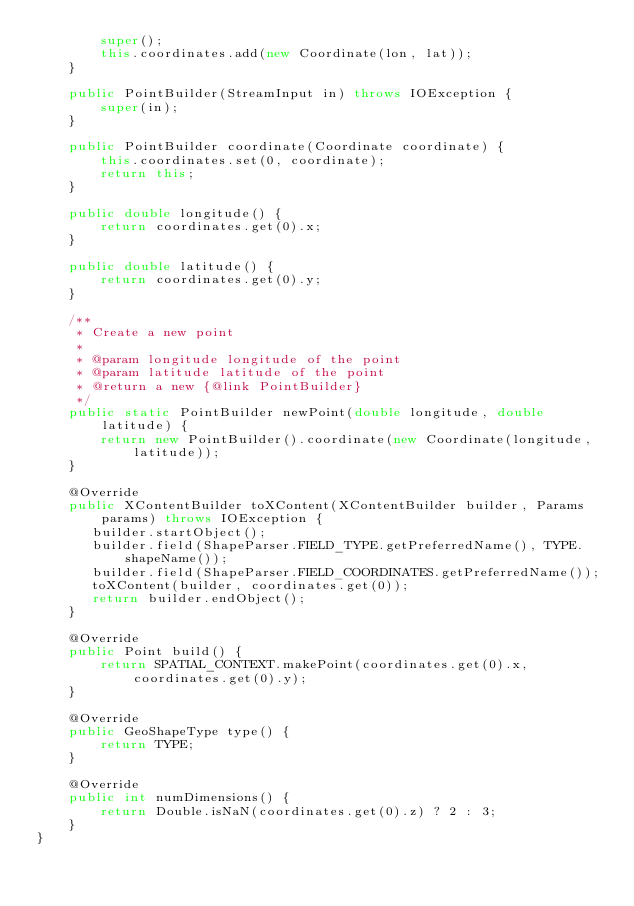Convert code to text. <code><loc_0><loc_0><loc_500><loc_500><_Java_>        super();
        this.coordinates.add(new Coordinate(lon, lat));
    }

    public PointBuilder(StreamInput in) throws IOException {
        super(in);
    }

    public PointBuilder coordinate(Coordinate coordinate) {
        this.coordinates.set(0, coordinate);
        return this;
    }

    public double longitude() {
        return coordinates.get(0).x;
    }

    public double latitude() {
        return coordinates.get(0).y;
    }

    /**
     * Create a new point
     *
     * @param longitude longitude of the point
     * @param latitude latitude of the point
     * @return a new {@link PointBuilder}
     */
    public static PointBuilder newPoint(double longitude, double latitude) {
        return new PointBuilder().coordinate(new Coordinate(longitude, latitude));
    }

    @Override
    public XContentBuilder toXContent(XContentBuilder builder, Params params) throws IOException {
       builder.startObject();
       builder.field(ShapeParser.FIELD_TYPE.getPreferredName(), TYPE.shapeName());
       builder.field(ShapeParser.FIELD_COORDINATES.getPreferredName());
       toXContent(builder, coordinates.get(0));
       return builder.endObject();
    }

    @Override
    public Point build() {
        return SPATIAL_CONTEXT.makePoint(coordinates.get(0).x, coordinates.get(0).y);
    }

    @Override
    public GeoShapeType type() {
        return TYPE;
    }

    @Override
    public int numDimensions() {
        return Double.isNaN(coordinates.get(0).z) ? 2 : 3;
    }
}
</code> 